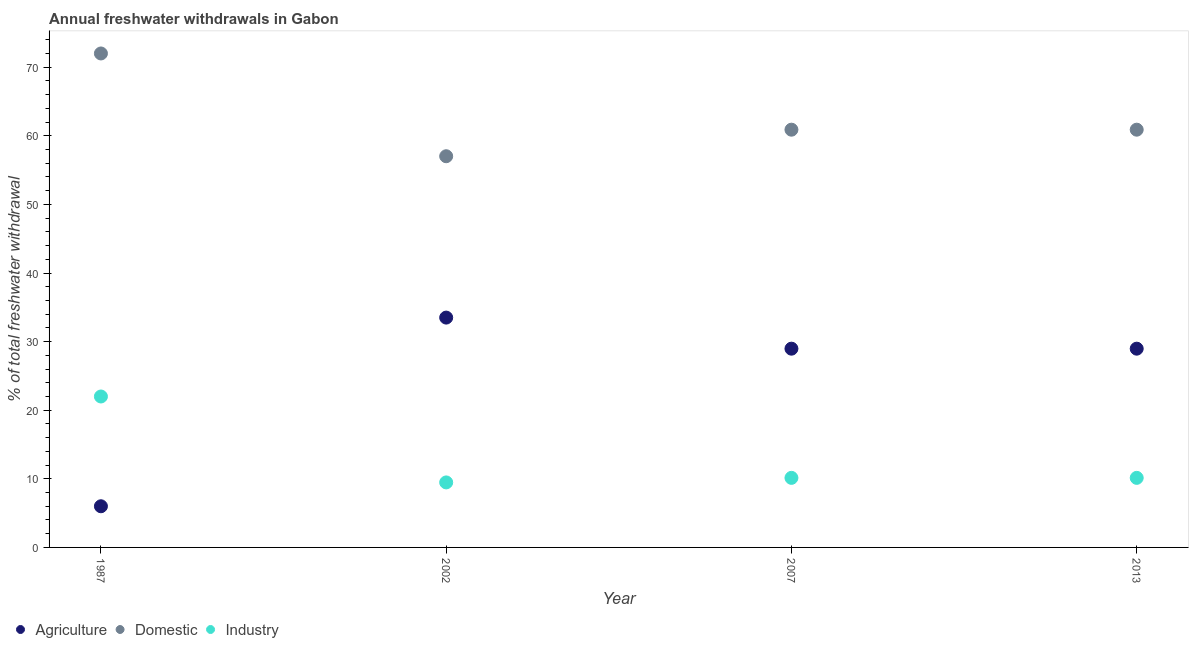What is the percentage of freshwater withdrawal for domestic purposes in 2007?
Provide a short and direct response. 60.89. Across all years, what is the minimum percentage of freshwater withdrawal for domestic purposes?
Make the answer very short. 57.02. In which year was the percentage of freshwater withdrawal for agriculture minimum?
Your answer should be very brief. 1987. What is the total percentage of freshwater withdrawal for domestic purposes in the graph?
Offer a very short reply. 250.8. What is the difference between the percentage of freshwater withdrawal for domestic purposes in 2002 and that in 2007?
Provide a short and direct response. -3.87. What is the difference between the percentage of freshwater withdrawal for domestic purposes in 2007 and the percentage of freshwater withdrawal for industry in 2002?
Make the answer very short. 51.41. What is the average percentage of freshwater withdrawal for agriculture per year?
Give a very brief answer. 24.36. In how many years, is the percentage of freshwater withdrawal for industry greater than 24 %?
Provide a succinct answer. 0. What is the ratio of the percentage of freshwater withdrawal for industry in 1987 to that in 2002?
Offer a terse response. 2.32. Is the percentage of freshwater withdrawal for domestic purposes in 1987 less than that in 2013?
Provide a short and direct response. No. Is the difference between the percentage of freshwater withdrawal for domestic purposes in 1987 and 2007 greater than the difference between the percentage of freshwater withdrawal for industry in 1987 and 2007?
Offer a very short reply. No. What is the difference between the highest and the second highest percentage of freshwater withdrawal for agriculture?
Offer a very short reply. 4.53. Is the sum of the percentage of freshwater withdrawal for agriculture in 2007 and 2013 greater than the maximum percentage of freshwater withdrawal for industry across all years?
Ensure brevity in your answer.  Yes. Is the percentage of freshwater withdrawal for industry strictly less than the percentage of freshwater withdrawal for agriculture over the years?
Provide a succinct answer. No. How many years are there in the graph?
Give a very brief answer. 4. What is the difference between two consecutive major ticks on the Y-axis?
Your answer should be very brief. 10. Does the graph contain any zero values?
Your response must be concise. No. Does the graph contain grids?
Offer a terse response. No. How many legend labels are there?
Offer a very short reply. 3. What is the title of the graph?
Ensure brevity in your answer.  Annual freshwater withdrawals in Gabon. Does "Other sectors" appear as one of the legend labels in the graph?
Give a very brief answer. No. What is the label or title of the Y-axis?
Ensure brevity in your answer.  % of total freshwater withdrawal. What is the % of total freshwater withdrawal in Agriculture in 1987?
Your response must be concise. 6. What is the % of total freshwater withdrawal of Domestic in 1987?
Keep it short and to the point. 72. What is the % of total freshwater withdrawal in Industry in 1987?
Your response must be concise. 22. What is the % of total freshwater withdrawal of Agriculture in 2002?
Offer a very short reply. 33.5. What is the % of total freshwater withdrawal in Domestic in 2002?
Offer a very short reply. 57.02. What is the % of total freshwater withdrawal in Industry in 2002?
Keep it short and to the point. 9.48. What is the % of total freshwater withdrawal in Agriculture in 2007?
Offer a very short reply. 28.97. What is the % of total freshwater withdrawal in Domestic in 2007?
Provide a succinct answer. 60.89. What is the % of total freshwater withdrawal of Industry in 2007?
Your response must be concise. 10.14. What is the % of total freshwater withdrawal in Agriculture in 2013?
Ensure brevity in your answer.  28.97. What is the % of total freshwater withdrawal of Domestic in 2013?
Make the answer very short. 60.89. What is the % of total freshwater withdrawal of Industry in 2013?
Provide a short and direct response. 10.14. Across all years, what is the maximum % of total freshwater withdrawal of Agriculture?
Your response must be concise. 33.5. Across all years, what is the maximum % of total freshwater withdrawal of Domestic?
Ensure brevity in your answer.  72. Across all years, what is the maximum % of total freshwater withdrawal of Industry?
Offer a terse response. 22. Across all years, what is the minimum % of total freshwater withdrawal in Domestic?
Your answer should be compact. 57.02. Across all years, what is the minimum % of total freshwater withdrawal of Industry?
Provide a short and direct response. 9.48. What is the total % of total freshwater withdrawal in Agriculture in the graph?
Ensure brevity in your answer.  97.44. What is the total % of total freshwater withdrawal of Domestic in the graph?
Your response must be concise. 250.8. What is the total % of total freshwater withdrawal in Industry in the graph?
Offer a very short reply. 51.76. What is the difference between the % of total freshwater withdrawal of Agriculture in 1987 and that in 2002?
Your answer should be very brief. -27.5. What is the difference between the % of total freshwater withdrawal in Domestic in 1987 and that in 2002?
Offer a very short reply. 14.98. What is the difference between the % of total freshwater withdrawal in Industry in 1987 and that in 2002?
Give a very brief answer. 12.52. What is the difference between the % of total freshwater withdrawal in Agriculture in 1987 and that in 2007?
Provide a succinct answer. -22.97. What is the difference between the % of total freshwater withdrawal in Domestic in 1987 and that in 2007?
Offer a very short reply. 11.11. What is the difference between the % of total freshwater withdrawal in Industry in 1987 and that in 2007?
Make the answer very short. 11.86. What is the difference between the % of total freshwater withdrawal of Agriculture in 1987 and that in 2013?
Your answer should be compact. -22.97. What is the difference between the % of total freshwater withdrawal in Domestic in 1987 and that in 2013?
Keep it short and to the point. 11.11. What is the difference between the % of total freshwater withdrawal in Industry in 1987 and that in 2013?
Provide a succinct answer. 11.86. What is the difference between the % of total freshwater withdrawal of Agriculture in 2002 and that in 2007?
Your response must be concise. 4.53. What is the difference between the % of total freshwater withdrawal in Domestic in 2002 and that in 2007?
Provide a short and direct response. -3.87. What is the difference between the % of total freshwater withdrawal in Industry in 2002 and that in 2007?
Give a very brief answer. -0.66. What is the difference between the % of total freshwater withdrawal in Agriculture in 2002 and that in 2013?
Offer a terse response. 4.53. What is the difference between the % of total freshwater withdrawal in Domestic in 2002 and that in 2013?
Keep it short and to the point. -3.87. What is the difference between the % of total freshwater withdrawal in Industry in 2002 and that in 2013?
Provide a short and direct response. -0.66. What is the difference between the % of total freshwater withdrawal in Agriculture in 1987 and the % of total freshwater withdrawal in Domestic in 2002?
Your answer should be very brief. -51.02. What is the difference between the % of total freshwater withdrawal in Agriculture in 1987 and the % of total freshwater withdrawal in Industry in 2002?
Provide a short and direct response. -3.48. What is the difference between the % of total freshwater withdrawal of Domestic in 1987 and the % of total freshwater withdrawal of Industry in 2002?
Your answer should be compact. 62.52. What is the difference between the % of total freshwater withdrawal of Agriculture in 1987 and the % of total freshwater withdrawal of Domestic in 2007?
Provide a succinct answer. -54.89. What is the difference between the % of total freshwater withdrawal in Agriculture in 1987 and the % of total freshwater withdrawal in Industry in 2007?
Your answer should be compact. -4.14. What is the difference between the % of total freshwater withdrawal in Domestic in 1987 and the % of total freshwater withdrawal in Industry in 2007?
Your answer should be compact. 61.86. What is the difference between the % of total freshwater withdrawal in Agriculture in 1987 and the % of total freshwater withdrawal in Domestic in 2013?
Your response must be concise. -54.89. What is the difference between the % of total freshwater withdrawal in Agriculture in 1987 and the % of total freshwater withdrawal in Industry in 2013?
Make the answer very short. -4.14. What is the difference between the % of total freshwater withdrawal of Domestic in 1987 and the % of total freshwater withdrawal of Industry in 2013?
Give a very brief answer. 61.86. What is the difference between the % of total freshwater withdrawal in Agriculture in 2002 and the % of total freshwater withdrawal in Domestic in 2007?
Provide a short and direct response. -27.39. What is the difference between the % of total freshwater withdrawal of Agriculture in 2002 and the % of total freshwater withdrawal of Industry in 2007?
Provide a succinct answer. 23.36. What is the difference between the % of total freshwater withdrawal in Domestic in 2002 and the % of total freshwater withdrawal in Industry in 2007?
Offer a terse response. 46.88. What is the difference between the % of total freshwater withdrawal in Agriculture in 2002 and the % of total freshwater withdrawal in Domestic in 2013?
Your response must be concise. -27.39. What is the difference between the % of total freshwater withdrawal in Agriculture in 2002 and the % of total freshwater withdrawal in Industry in 2013?
Offer a very short reply. 23.36. What is the difference between the % of total freshwater withdrawal in Domestic in 2002 and the % of total freshwater withdrawal in Industry in 2013?
Your answer should be compact. 46.88. What is the difference between the % of total freshwater withdrawal in Agriculture in 2007 and the % of total freshwater withdrawal in Domestic in 2013?
Provide a succinct answer. -31.92. What is the difference between the % of total freshwater withdrawal of Agriculture in 2007 and the % of total freshwater withdrawal of Industry in 2013?
Make the answer very short. 18.83. What is the difference between the % of total freshwater withdrawal of Domestic in 2007 and the % of total freshwater withdrawal of Industry in 2013?
Provide a short and direct response. 50.75. What is the average % of total freshwater withdrawal of Agriculture per year?
Ensure brevity in your answer.  24.36. What is the average % of total freshwater withdrawal in Domestic per year?
Offer a very short reply. 62.7. What is the average % of total freshwater withdrawal of Industry per year?
Provide a succinct answer. 12.94. In the year 1987, what is the difference between the % of total freshwater withdrawal of Agriculture and % of total freshwater withdrawal of Domestic?
Your answer should be very brief. -66. In the year 1987, what is the difference between the % of total freshwater withdrawal in Domestic and % of total freshwater withdrawal in Industry?
Your answer should be compact. 50. In the year 2002, what is the difference between the % of total freshwater withdrawal of Agriculture and % of total freshwater withdrawal of Domestic?
Offer a terse response. -23.52. In the year 2002, what is the difference between the % of total freshwater withdrawal of Agriculture and % of total freshwater withdrawal of Industry?
Give a very brief answer. 24.02. In the year 2002, what is the difference between the % of total freshwater withdrawal of Domestic and % of total freshwater withdrawal of Industry?
Offer a terse response. 47.54. In the year 2007, what is the difference between the % of total freshwater withdrawal of Agriculture and % of total freshwater withdrawal of Domestic?
Ensure brevity in your answer.  -31.92. In the year 2007, what is the difference between the % of total freshwater withdrawal in Agriculture and % of total freshwater withdrawal in Industry?
Your answer should be compact. 18.83. In the year 2007, what is the difference between the % of total freshwater withdrawal of Domestic and % of total freshwater withdrawal of Industry?
Provide a short and direct response. 50.75. In the year 2013, what is the difference between the % of total freshwater withdrawal of Agriculture and % of total freshwater withdrawal of Domestic?
Your answer should be compact. -31.92. In the year 2013, what is the difference between the % of total freshwater withdrawal of Agriculture and % of total freshwater withdrawal of Industry?
Your response must be concise. 18.83. In the year 2013, what is the difference between the % of total freshwater withdrawal of Domestic and % of total freshwater withdrawal of Industry?
Your answer should be compact. 50.75. What is the ratio of the % of total freshwater withdrawal of Agriculture in 1987 to that in 2002?
Provide a short and direct response. 0.18. What is the ratio of the % of total freshwater withdrawal of Domestic in 1987 to that in 2002?
Provide a short and direct response. 1.26. What is the ratio of the % of total freshwater withdrawal of Industry in 1987 to that in 2002?
Give a very brief answer. 2.32. What is the ratio of the % of total freshwater withdrawal in Agriculture in 1987 to that in 2007?
Provide a succinct answer. 0.21. What is the ratio of the % of total freshwater withdrawal of Domestic in 1987 to that in 2007?
Offer a very short reply. 1.18. What is the ratio of the % of total freshwater withdrawal in Industry in 1987 to that in 2007?
Give a very brief answer. 2.17. What is the ratio of the % of total freshwater withdrawal in Agriculture in 1987 to that in 2013?
Provide a succinct answer. 0.21. What is the ratio of the % of total freshwater withdrawal in Domestic in 1987 to that in 2013?
Ensure brevity in your answer.  1.18. What is the ratio of the % of total freshwater withdrawal in Industry in 1987 to that in 2013?
Offer a very short reply. 2.17. What is the ratio of the % of total freshwater withdrawal in Agriculture in 2002 to that in 2007?
Your answer should be compact. 1.16. What is the ratio of the % of total freshwater withdrawal in Domestic in 2002 to that in 2007?
Keep it short and to the point. 0.94. What is the ratio of the % of total freshwater withdrawal in Industry in 2002 to that in 2007?
Keep it short and to the point. 0.93. What is the ratio of the % of total freshwater withdrawal in Agriculture in 2002 to that in 2013?
Make the answer very short. 1.16. What is the ratio of the % of total freshwater withdrawal in Domestic in 2002 to that in 2013?
Offer a very short reply. 0.94. What is the ratio of the % of total freshwater withdrawal in Industry in 2002 to that in 2013?
Your response must be concise. 0.93. What is the ratio of the % of total freshwater withdrawal in Agriculture in 2007 to that in 2013?
Your answer should be very brief. 1. What is the ratio of the % of total freshwater withdrawal of Industry in 2007 to that in 2013?
Offer a very short reply. 1. What is the difference between the highest and the second highest % of total freshwater withdrawal of Agriculture?
Offer a very short reply. 4.53. What is the difference between the highest and the second highest % of total freshwater withdrawal of Domestic?
Offer a terse response. 11.11. What is the difference between the highest and the second highest % of total freshwater withdrawal in Industry?
Make the answer very short. 11.86. What is the difference between the highest and the lowest % of total freshwater withdrawal of Domestic?
Keep it short and to the point. 14.98. What is the difference between the highest and the lowest % of total freshwater withdrawal in Industry?
Offer a terse response. 12.52. 